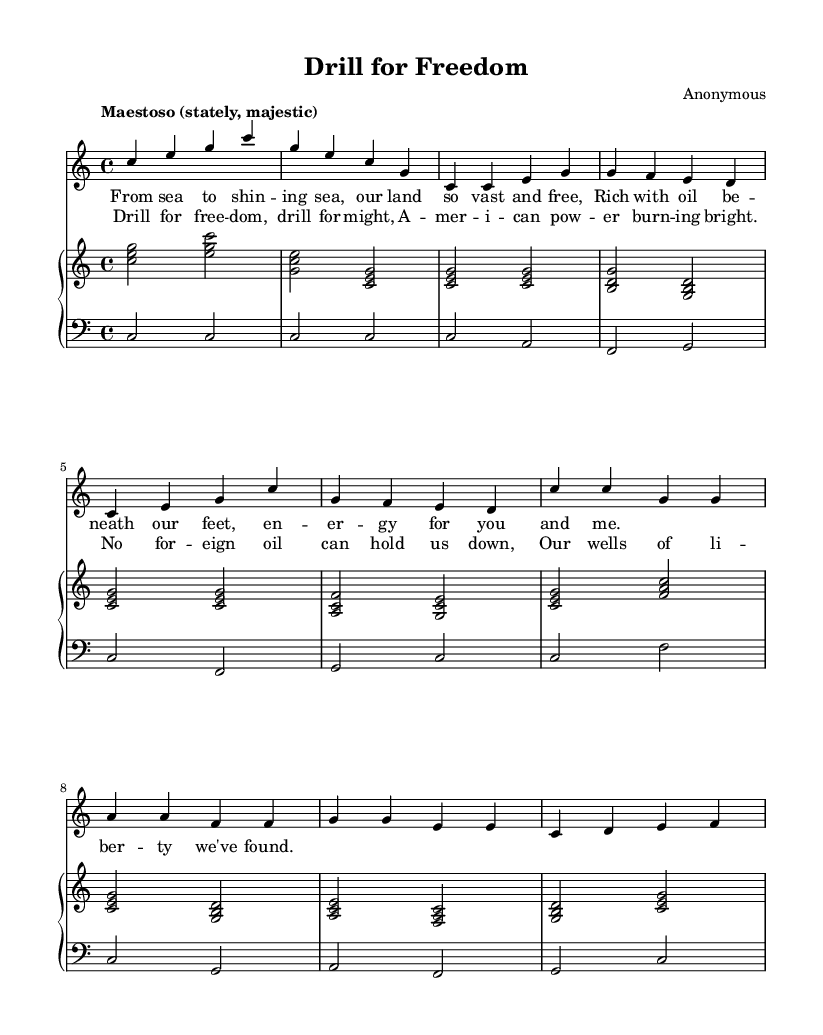What is the key signature of this music? The key signature is indicated at the beginning of the staff and shows no sharps or flats, indicating that it is in C major.
Answer: C major What is the time signature of this music? The time signature is shown at the beginning of the score, which indicates a rhythm of four beats per measure.
Answer: 4/4 What is the tempo marking of this piece? The tempo marking appears just below the title, stating "Maestoso," which suggests a majestic and stately tempo.
Answer: Maestoso How many measures are present in the soprano part? By counting each measure represented in the soprano voice line, there are a total of 10 measures visible.
Answer: 10 What is the primary theme expressed in the lyrics? The lyrics convey a message celebrating energy independence, with phrases like "Drill for freedom" and "American power burning bright."
Answer: Energy independence What is the structure of the vocal parts in this piece? The vocal parts consist of an introduction followed by a verse and then a chorus, indicating a typical operatic structure of alternating sections.
Answer: Introduction, Verse, Chorus What type of voice is featured in the melody? The score specifies that the melody is sung by the soprano voice, which is indicated at the beginning of that voice part.
Answer: Soprano 